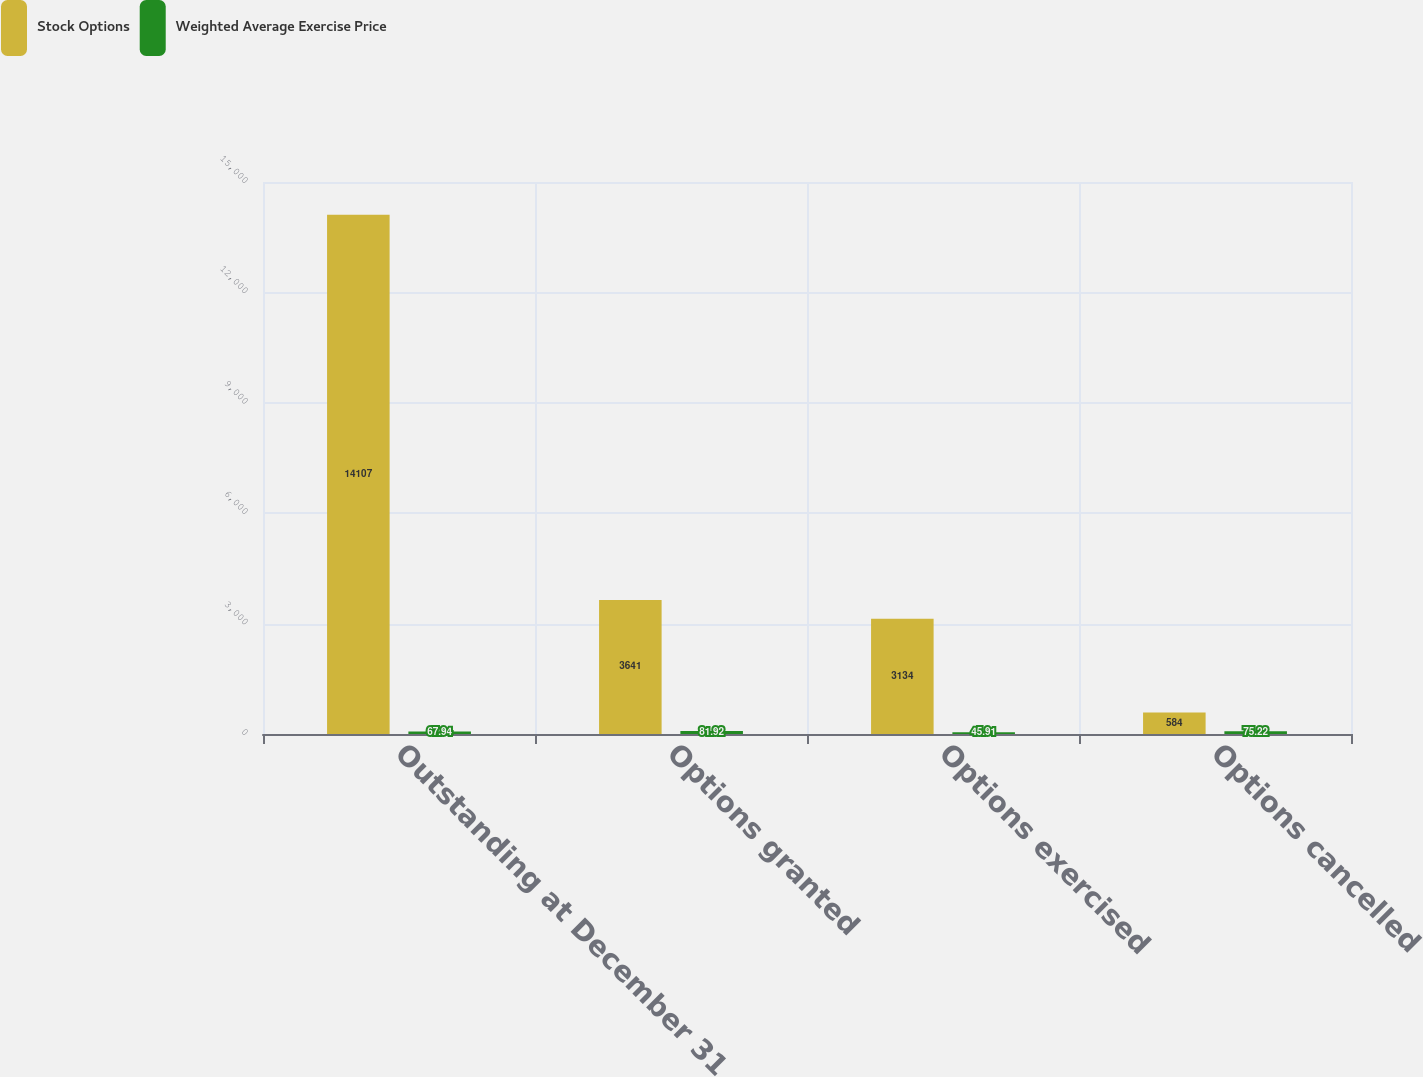Convert chart to OTSL. <chart><loc_0><loc_0><loc_500><loc_500><stacked_bar_chart><ecel><fcel>Outstanding at December 31<fcel>Options granted<fcel>Options exercised<fcel>Options cancelled<nl><fcel>Stock Options<fcel>14107<fcel>3641<fcel>3134<fcel>584<nl><fcel>Weighted Average Exercise Price<fcel>67.94<fcel>81.92<fcel>45.91<fcel>75.22<nl></chart> 